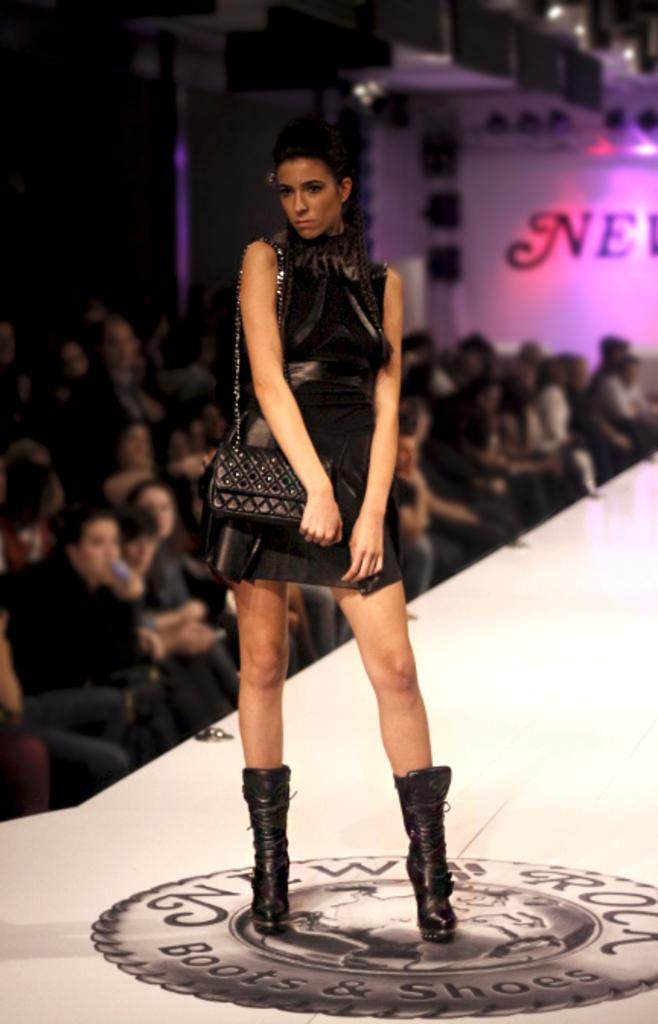What is the primary action of the person in the image? There is a person standing in the image. What is the person wearing that is visible in the image? The person is wearing a bag. What can be seen to the right of the standing person? There is a group of people sitting to the right of the standing person. What is visible in the background of the image? There is a board visible in the background of the image. How many children are playing with the stem in the image? There are no children or stems present in the image. 